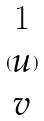<formula> <loc_0><loc_0><loc_500><loc_500>( \begin{matrix} 1 \\ u \\ v \end{matrix} )</formula> 